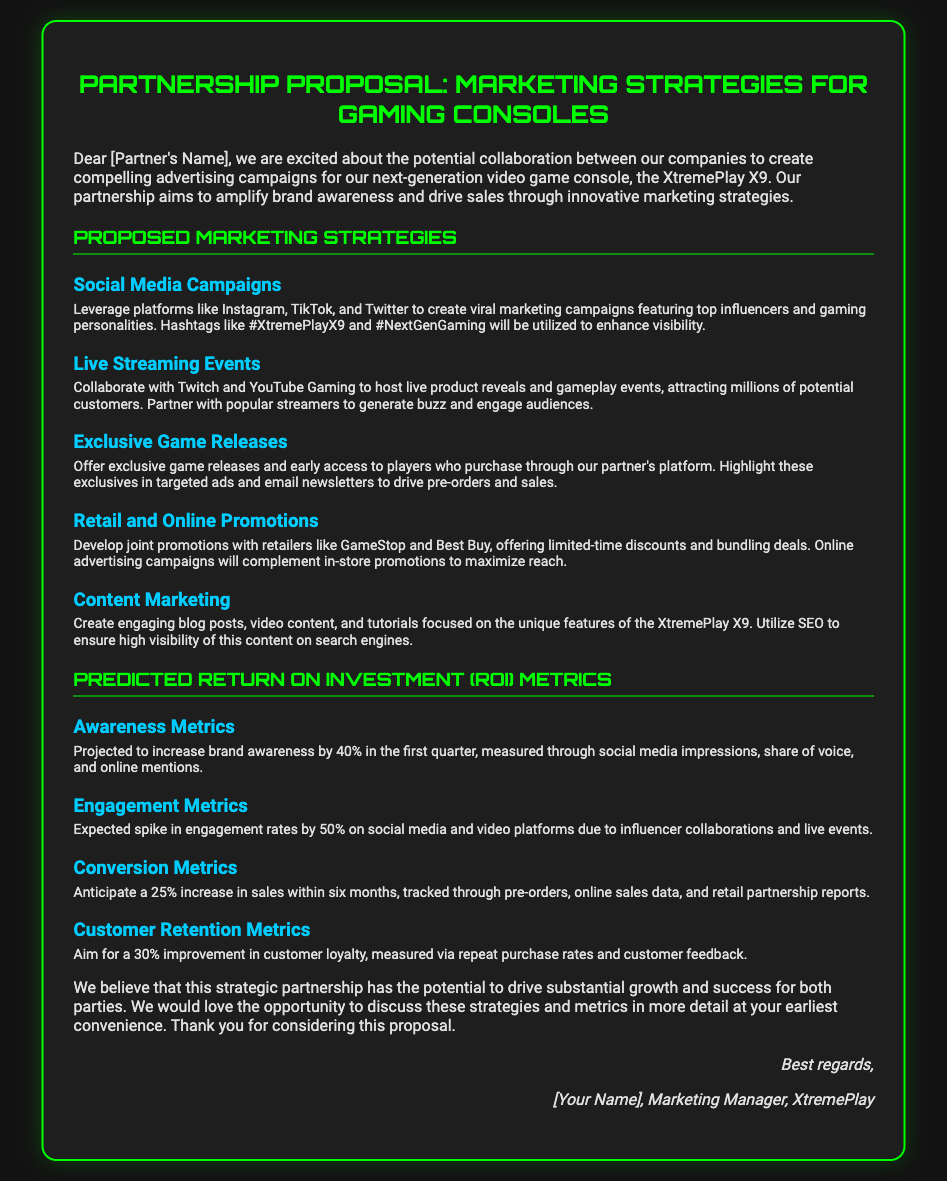What is the name of the console? The console being marketed in the proposal is explicitly referred to as the "XtremePlay X9."
Answer: XtremePlay X9 What is the projected increase in brand awareness? The document states a projected increase in brand awareness by "40%" in the first quarter.
Answer: 40% Which platforms are suggested for the Social Media Campaigns? The document lists "Instagram, TikTok, and Twitter" as the platforms for the campaigns.
Answer: Instagram, TikTok, Twitter What is the aim for customer loyalty improvement? The proposal aims for a "30% improvement in customer loyalty" as indicated in the metrics section.
Answer: 30% What is one way to measure engagement metrics? The increase in engagement rates is expected to be measured through "social media and video platforms."
Answer: Social media and video platforms How many marketing strategies are proposed? The document outlines a total of "five" different marketing strategies.
Answer: Five What type of events is proposed to generate buzz? "Live Streaming Events" is the proposed type of event to generate buzz as per the marketing strategies.
Answer: Live Streaming Events What is the expected sales increase within six months? The proposed plan anticipates a "25% increase in sales" within six months.
Answer: 25% What position does the sender hold? The document indicates the sender's position as "Marketing Manager."
Answer: Marketing Manager 